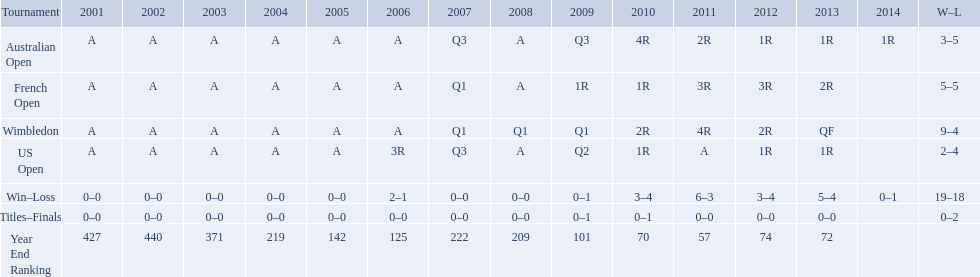In what years was a ranking beneath 200 attained? 2005, 2006, 2009, 2010, 2011, 2012, 2013. 